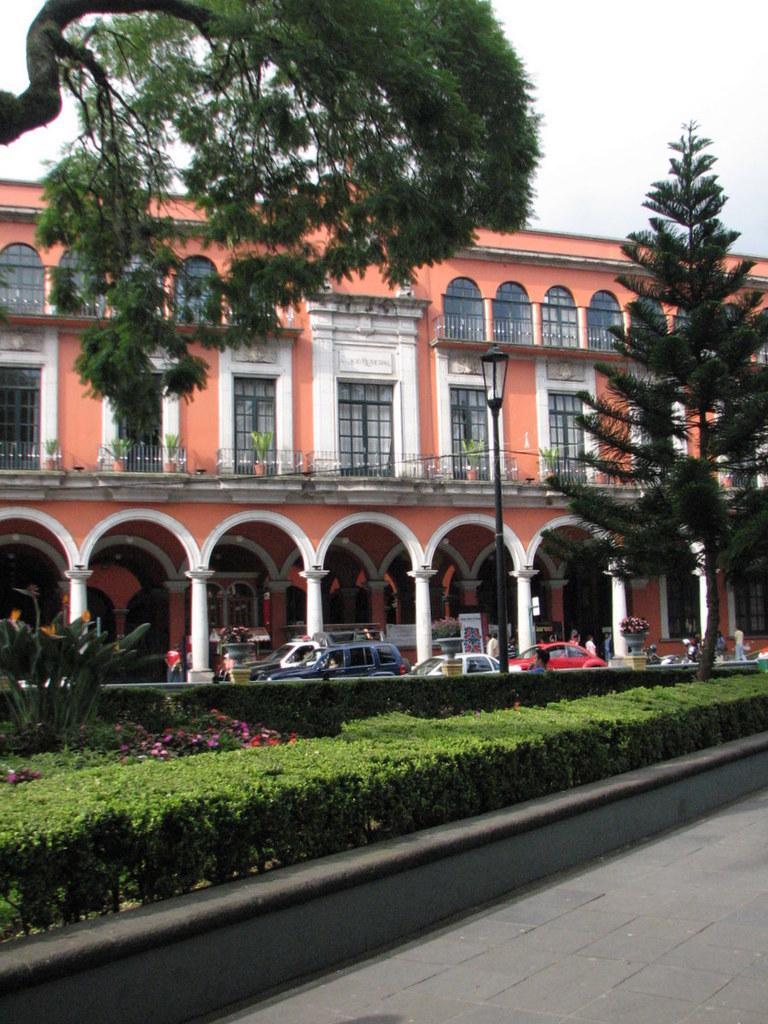Describe this image in one or two sentences. This is the picture of a building. In this image there are vehicles on the road. There are group of people walking on the footpath and there is a pole on the footpath. At the back there is a building and there are trees. At the top there is sky. At the bottom there is a road and there are plants and flowers. 